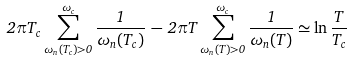<formula> <loc_0><loc_0><loc_500><loc_500>2 \pi T _ { c } \sum _ { \omega _ { n } ( T _ { c } ) > 0 } ^ { \omega _ { c } } \frac { 1 } { \omega _ { n } ( T _ { c } ) } \, - \, 2 \pi T \sum _ { \omega _ { n } ( T ) > 0 } ^ { \omega _ { c } } \frac { 1 } { \omega _ { n } ( T ) } \simeq \ln \frac { T } { T _ { c } }</formula> 